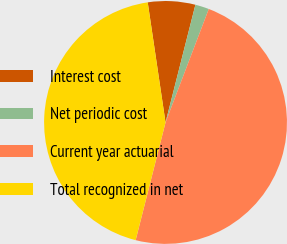Convert chart to OTSL. <chart><loc_0><loc_0><loc_500><loc_500><pie_chart><fcel>Interest cost<fcel>Net periodic cost<fcel>Current year actuarial<fcel>Total recognized in net<nl><fcel>6.3%<fcel>1.84%<fcel>48.16%<fcel>43.7%<nl></chart> 